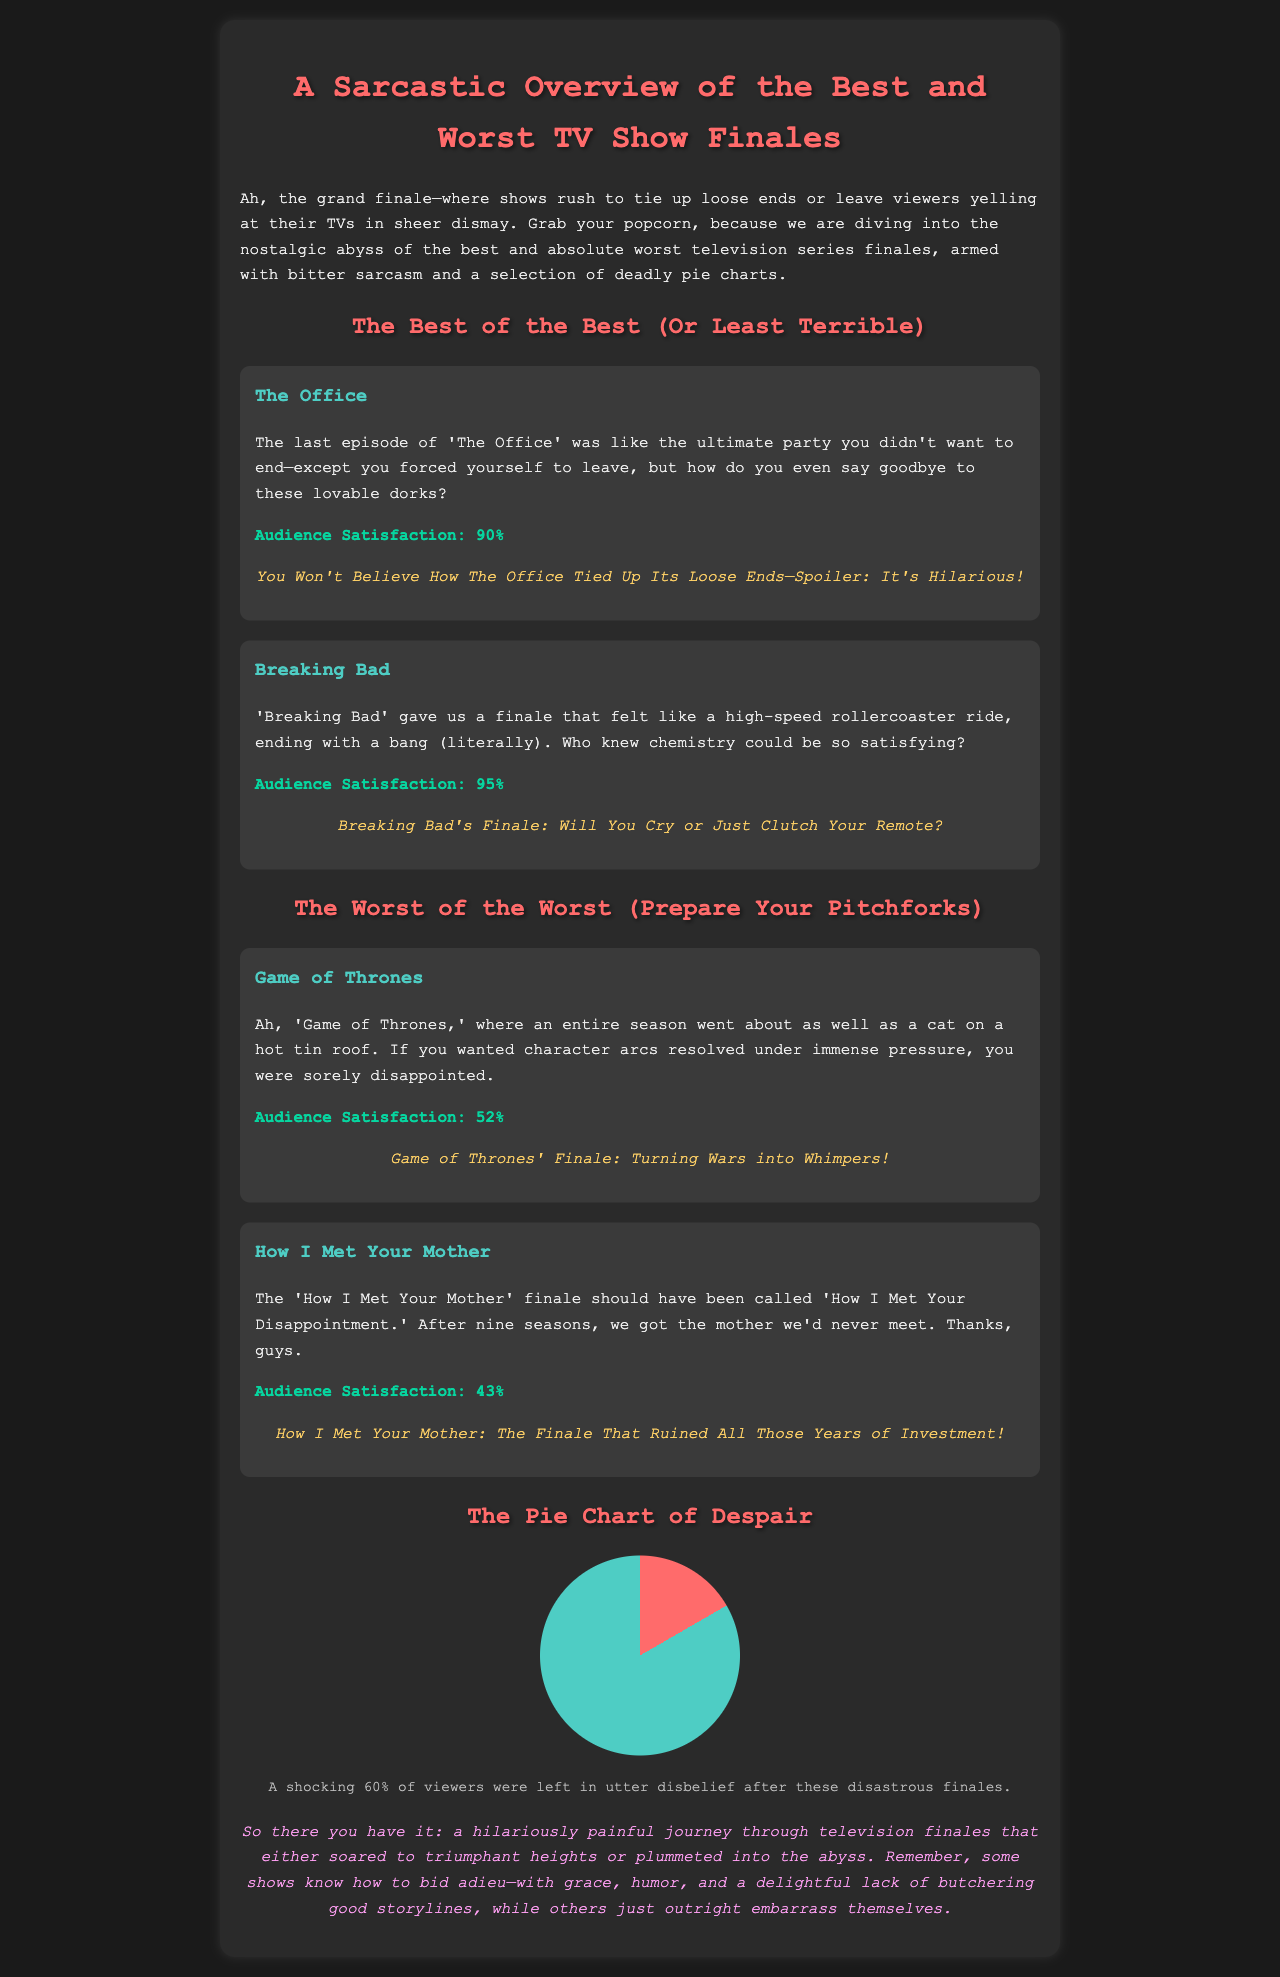What is the title of the document? The title of the document is displayed prominently at the top under the h1 tag.
Answer: A Sarcastic Overview of TV Show Finales What is the audience satisfaction for 'Breaking Bad'? The audience satisfaction percentage is specified in the section dedicated to 'Breaking Bad'.
Answer: 95% What percentage of viewers were dissatisfied with the 'Game of Thrones' finale? The document provides the audience satisfaction for 'Game of Thrones', indicating dissatisfaction.
Answer: 52% Which show’s finale is described as a 'party you didn't want to end'? The description is provided in the section for 'The Office' finale.
Answer: The Office What is the overall theme of the document? The document presents a sarcastic overview of television show finales, detailing the best and worst ones.
Answer: Sarcasm How many shows are mentioned in the 'The Worst of the Worst' section? This is a reasoning question based on the number of shows discussed in that specific section.
Answer: 2 What color scheme is used for the titles of the shows? The document specifies a color rule for the show titles that contributes to the visual styling.
Answer: #4ecdc4 What clickbait headline is used for 'How I Met Your Mother'? The specific clickbait headline for 'How I Met Your Mother' is quoted in its section.
Answer: How I Met Your Mother: The Finale That Ruined All Those Years of Investment! What does the pie chart represent? The description below the pie chart explains what it signifies about audience reactions.
Answer: A shocking 60% of viewers were left in utter disbelief after these disastrous finales 